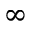<formula> <loc_0><loc_0><loc_500><loc_500>\infty</formula> 